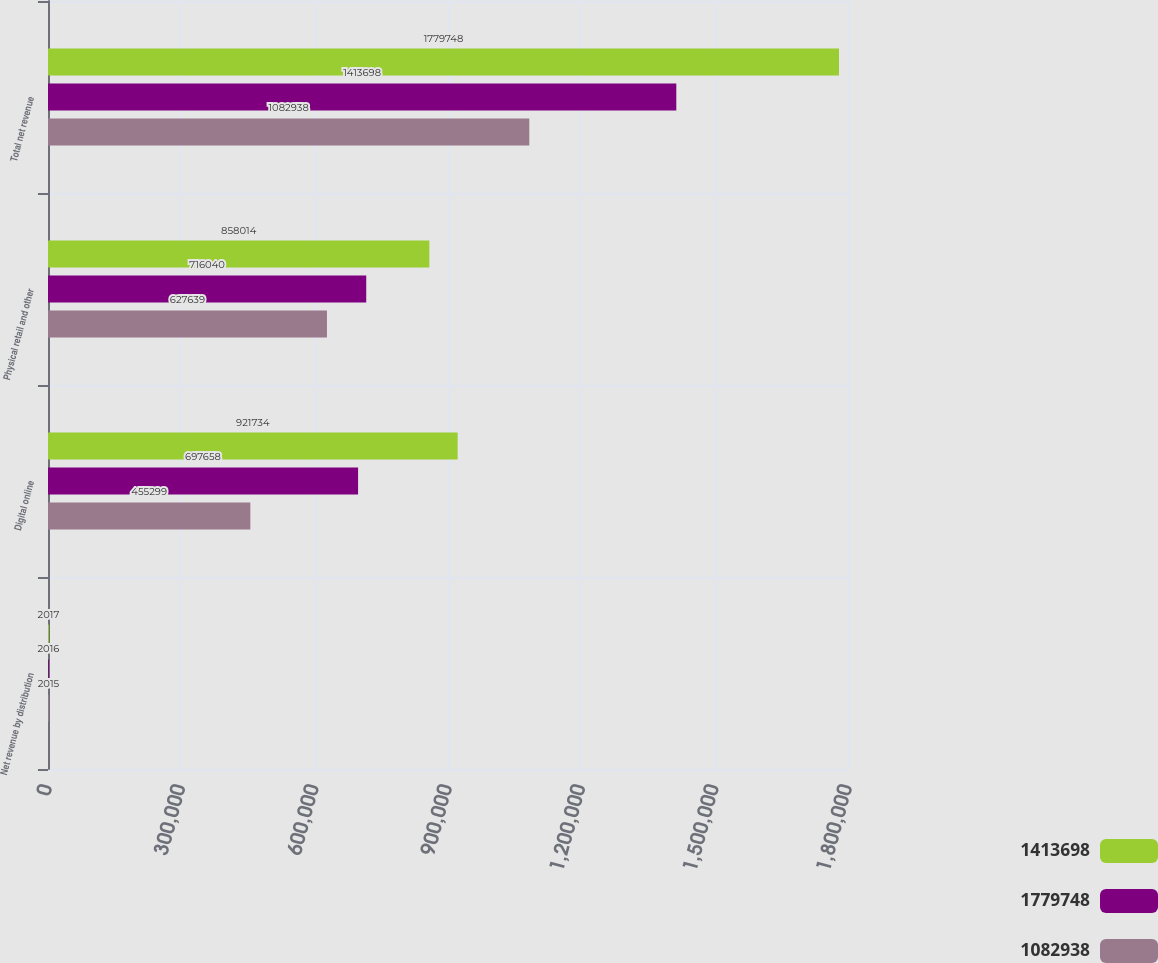Convert chart. <chart><loc_0><loc_0><loc_500><loc_500><stacked_bar_chart><ecel><fcel>Net revenue by distribution<fcel>Digital online<fcel>Physical retail and other<fcel>Total net revenue<nl><fcel>1.4137e+06<fcel>2017<fcel>921734<fcel>858014<fcel>1.77975e+06<nl><fcel>1.77975e+06<fcel>2016<fcel>697658<fcel>716040<fcel>1.4137e+06<nl><fcel>1.08294e+06<fcel>2015<fcel>455299<fcel>627639<fcel>1.08294e+06<nl></chart> 